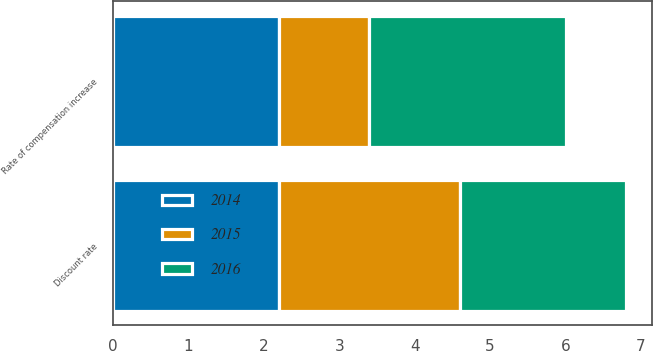<chart> <loc_0><loc_0><loc_500><loc_500><stacked_bar_chart><ecel><fcel>Discount rate<fcel>Rate of compensation increase<nl><fcel>2016<fcel>2.2<fcel>2.6<nl><fcel>2015<fcel>2.4<fcel>1.2<nl><fcel>2014<fcel>2.2<fcel>2.2<nl></chart> 